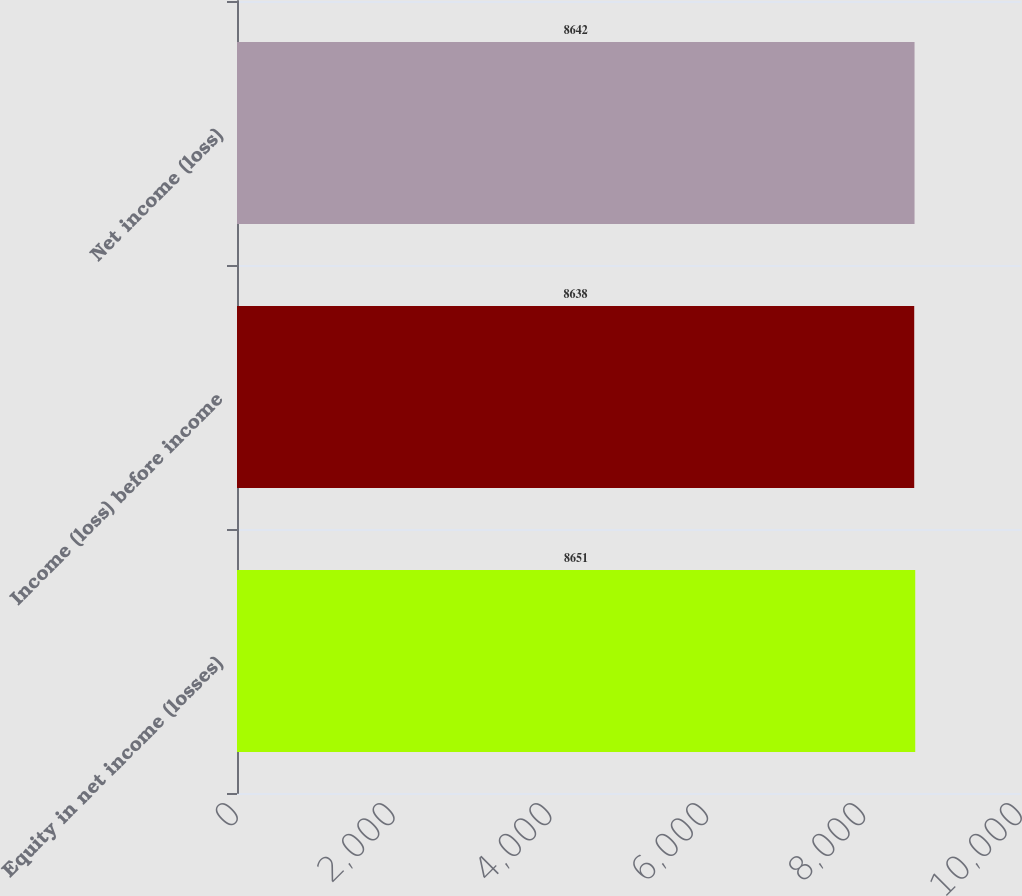<chart> <loc_0><loc_0><loc_500><loc_500><bar_chart><fcel>Equity in net income (losses)<fcel>Income (loss) before income<fcel>Net income (loss)<nl><fcel>8651<fcel>8638<fcel>8642<nl></chart> 